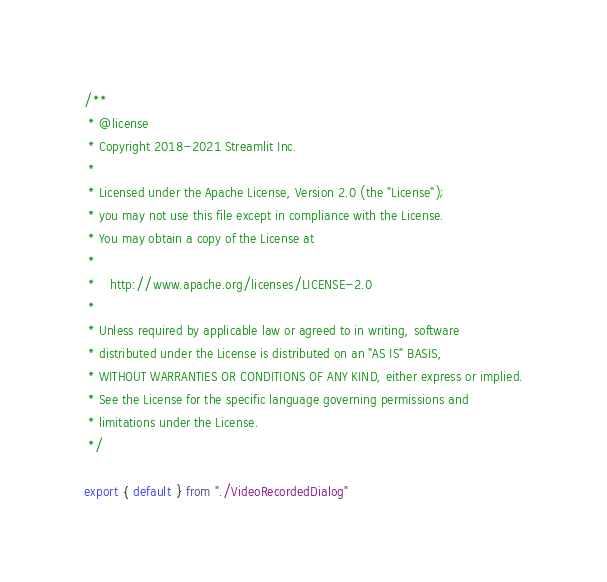<code> <loc_0><loc_0><loc_500><loc_500><_TypeScript_>/**
 * @license
 * Copyright 2018-2021 Streamlit Inc.
 *
 * Licensed under the Apache License, Version 2.0 (the "License");
 * you may not use this file except in compliance with the License.
 * You may obtain a copy of the License at
 *
 *    http://www.apache.org/licenses/LICENSE-2.0
 *
 * Unless required by applicable law or agreed to in writing, software
 * distributed under the License is distributed on an "AS IS" BASIS,
 * WITHOUT WARRANTIES OR CONDITIONS OF ANY KIND, either express or implied.
 * See the License for the specific language governing permissions and
 * limitations under the License.
 */

export { default } from "./VideoRecordedDialog"
</code> 